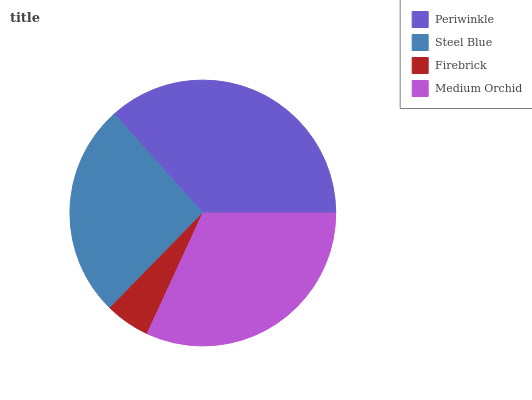Is Firebrick the minimum?
Answer yes or no. Yes. Is Periwinkle the maximum?
Answer yes or no. Yes. Is Steel Blue the minimum?
Answer yes or no. No. Is Steel Blue the maximum?
Answer yes or no. No. Is Periwinkle greater than Steel Blue?
Answer yes or no. Yes. Is Steel Blue less than Periwinkle?
Answer yes or no. Yes. Is Steel Blue greater than Periwinkle?
Answer yes or no. No. Is Periwinkle less than Steel Blue?
Answer yes or no. No. Is Medium Orchid the high median?
Answer yes or no. Yes. Is Steel Blue the low median?
Answer yes or no. Yes. Is Firebrick the high median?
Answer yes or no. No. Is Periwinkle the low median?
Answer yes or no. No. 